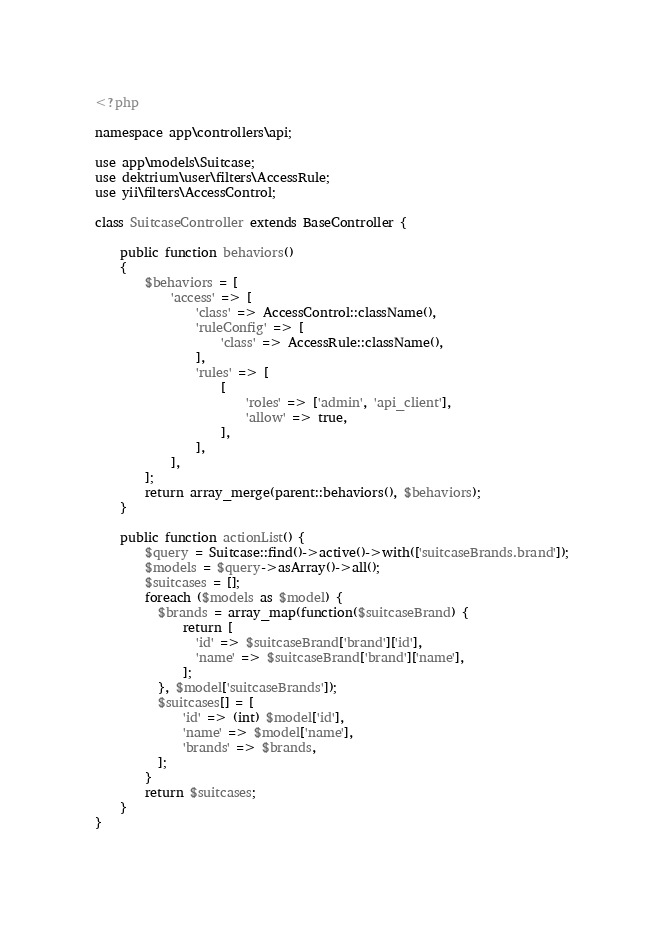Convert code to text. <code><loc_0><loc_0><loc_500><loc_500><_PHP_><?php

namespace app\controllers\api;

use app\models\Suitcase;
use dektrium\user\filters\AccessRule;
use yii\filters\AccessControl;

class SuitcaseController extends BaseController {

    public function behaviors()
    {
        $behaviors = [
            'access' => [
                'class' => AccessControl::className(),
                'ruleConfig' => [
                    'class' => AccessRule::className(),
                ],
                'rules' => [
                    [
                        'roles' => ['admin', 'api_client'],
                        'allow' => true,
                    ],
                ],
            ],
        ];
        return array_merge(parent::behaviors(), $behaviors);
    }

    public function actionList() {
        $query = Suitcase::find()->active()->with(['suitcaseBrands.brand']);
        $models = $query->asArray()->all();
        $suitcases = [];
        foreach ($models as $model) {
          $brands = array_map(function($suitcaseBrand) {
              return [
                'id' => $suitcaseBrand['brand']['id'],
                'name' => $suitcaseBrand['brand']['name'],
              ];
          }, $model['suitcaseBrands']);
          $suitcases[] = [
              'id' => (int) $model['id'],
              'name' => $model['name'],
              'brands' => $brands,
          ];
        }
        return $suitcases;
    }
}
</code> 